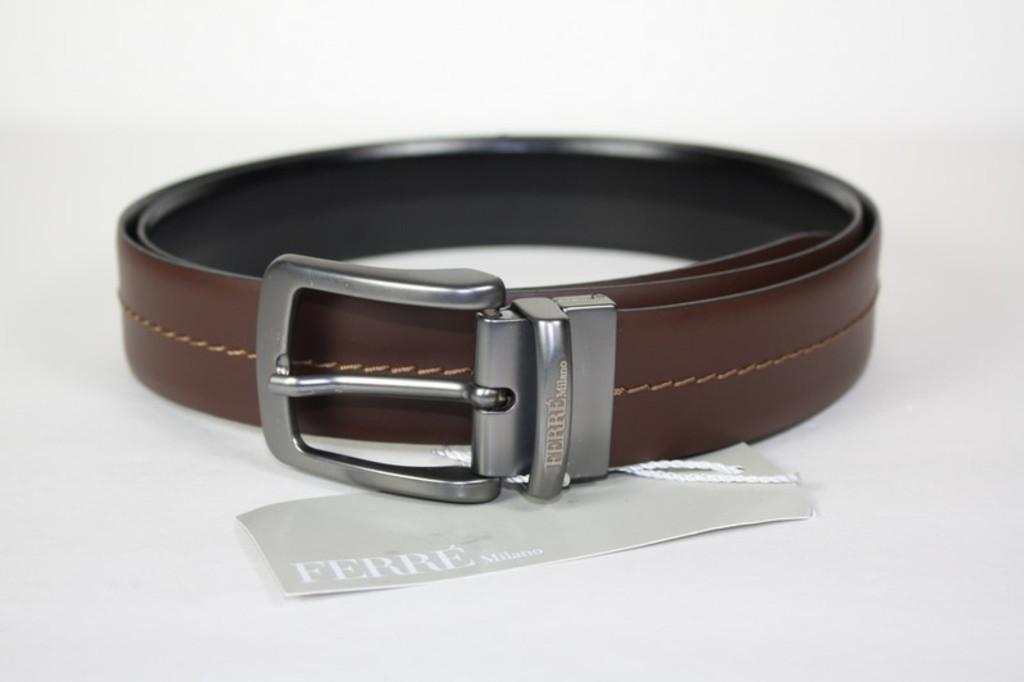What object can be seen in the image that is typically used for holding up pants? There is a leather belt in the image. What is attached to the leather belt? A piece of paper is attached to the belt. What can be found on the piece of paper? There is text on the paper. What color is the background of the image? The background of the image is white. How many things made of zinc can be seen in the image? There are no things made of zinc present in the image. What type of light source is illuminating the image? The provided facts do not mention any light source, so it cannot be determined from the image. 